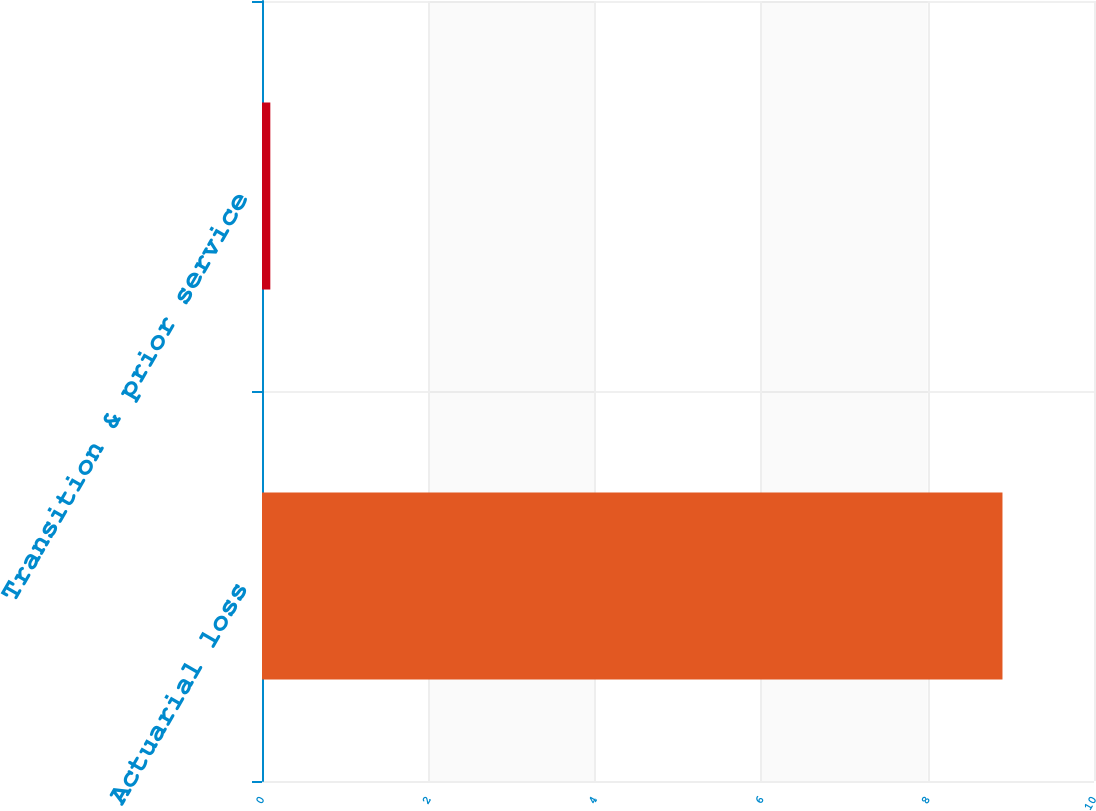<chart> <loc_0><loc_0><loc_500><loc_500><bar_chart><fcel>Actuarial loss<fcel>Transition & prior service<nl><fcel>8.9<fcel>0.1<nl></chart> 